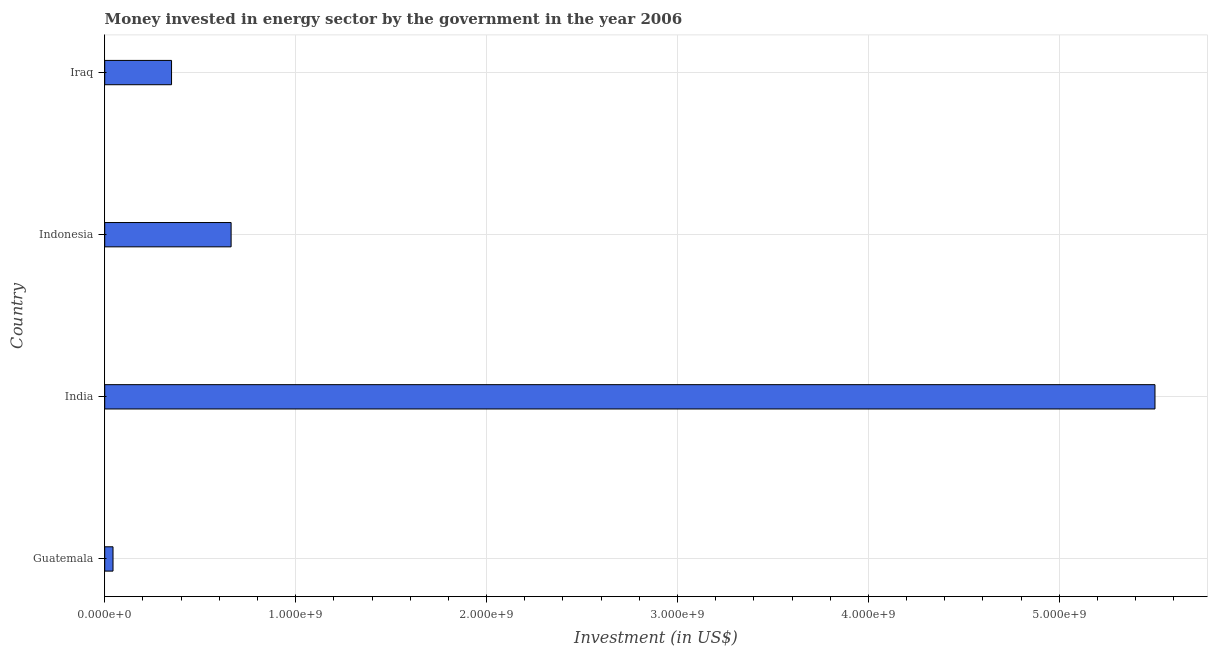Does the graph contain grids?
Your answer should be very brief. Yes. What is the title of the graph?
Provide a succinct answer. Money invested in energy sector by the government in the year 2006. What is the label or title of the X-axis?
Your answer should be very brief. Investment (in US$). What is the investment in energy in Indonesia?
Ensure brevity in your answer.  6.62e+08. Across all countries, what is the maximum investment in energy?
Give a very brief answer. 5.50e+09. Across all countries, what is the minimum investment in energy?
Provide a short and direct response. 4.35e+07. In which country was the investment in energy minimum?
Ensure brevity in your answer.  Guatemala. What is the sum of the investment in energy?
Keep it short and to the point. 6.56e+09. What is the difference between the investment in energy in India and Indonesia?
Offer a terse response. 4.84e+09. What is the average investment in energy per country?
Your response must be concise. 1.64e+09. What is the median investment in energy?
Keep it short and to the point. 5.06e+08. What is the ratio of the investment in energy in Guatemala to that in India?
Make the answer very short. 0.01. Is the investment in energy in India less than that in Iraq?
Your response must be concise. No. Is the difference between the investment in energy in Indonesia and Iraq greater than the difference between any two countries?
Your response must be concise. No. What is the difference between the highest and the second highest investment in energy?
Your answer should be compact. 4.84e+09. What is the difference between the highest and the lowest investment in energy?
Offer a very short reply. 5.46e+09. In how many countries, is the investment in energy greater than the average investment in energy taken over all countries?
Offer a very short reply. 1. How many bars are there?
Your answer should be compact. 4. Are all the bars in the graph horizontal?
Your answer should be very brief. Yes. How many countries are there in the graph?
Keep it short and to the point. 4. Are the values on the major ticks of X-axis written in scientific E-notation?
Keep it short and to the point. Yes. What is the Investment (in US$) of Guatemala?
Your response must be concise. 4.35e+07. What is the Investment (in US$) of India?
Provide a succinct answer. 5.50e+09. What is the Investment (in US$) in Indonesia?
Offer a very short reply. 6.62e+08. What is the Investment (in US$) in Iraq?
Your response must be concise. 3.50e+08. What is the difference between the Investment (in US$) in Guatemala and India?
Keep it short and to the point. -5.46e+09. What is the difference between the Investment (in US$) in Guatemala and Indonesia?
Give a very brief answer. -6.18e+08. What is the difference between the Investment (in US$) in Guatemala and Iraq?
Give a very brief answer. -3.06e+08. What is the difference between the Investment (in US$) in India and Indonesia?
Provide a short and direct response. 4.84e+09. What is the difference between the Investment (in US$) in India and Iraq?
Provide a short and direct response. 5.15e+09. What is the difference between the Investment (in US$) in Indonesia and Iraq?
Your response must be concise. 3.12e+08. What is the ratio of the Investment (in US$) in Guatemala to that in India?
Ensure brevity in your answer.  0.01. What is the ratio of the Investment (in US$) in Guatemala to that in Indonesia?
Keep it short and to the point. 0.07. What is the ratio of the Investment (in US$) in Guatemala to that in Iraq?
Your response must be concise. 0.12. What is the ratio of the Investment (in US$) in India to that in Indonesia?
Your answer should be compact. 8.31. What is the ratio of the Investment (in US$) in India to that in Iraq?
Ensure brevity in your answer.  15.72. What is the ratio of the Investment (in US$) in Indonesia to that in Iraq?
Make the answer very short. 1.89. 